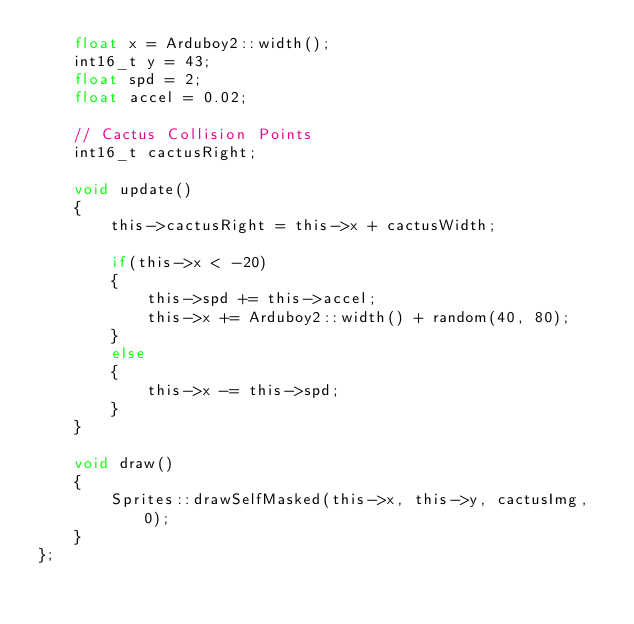<code> <loc_0><loc_0><loc_500><loc_500><_C_>    float x = Arduboy2::width();
    int16_t y = 43;
    float spd = 2;
    float accel = 0.02;

    // Cactus Collision Points
    int16_t cactusRight;

    void update()
    {
        this->cactusRight = this->x + cactusWidth;

        if(this->x < -20)
        {
            this->spd += this->accel;
            this->x += Arduboy2::width() + random(40, 80);
        }
        else
        {
            this->x -= this->spd;
        }
    }

    void draw()
    {
        Sprites::drawSelfMasked(this->x, this->y, cactusImg, 0);
    }
};</code> 